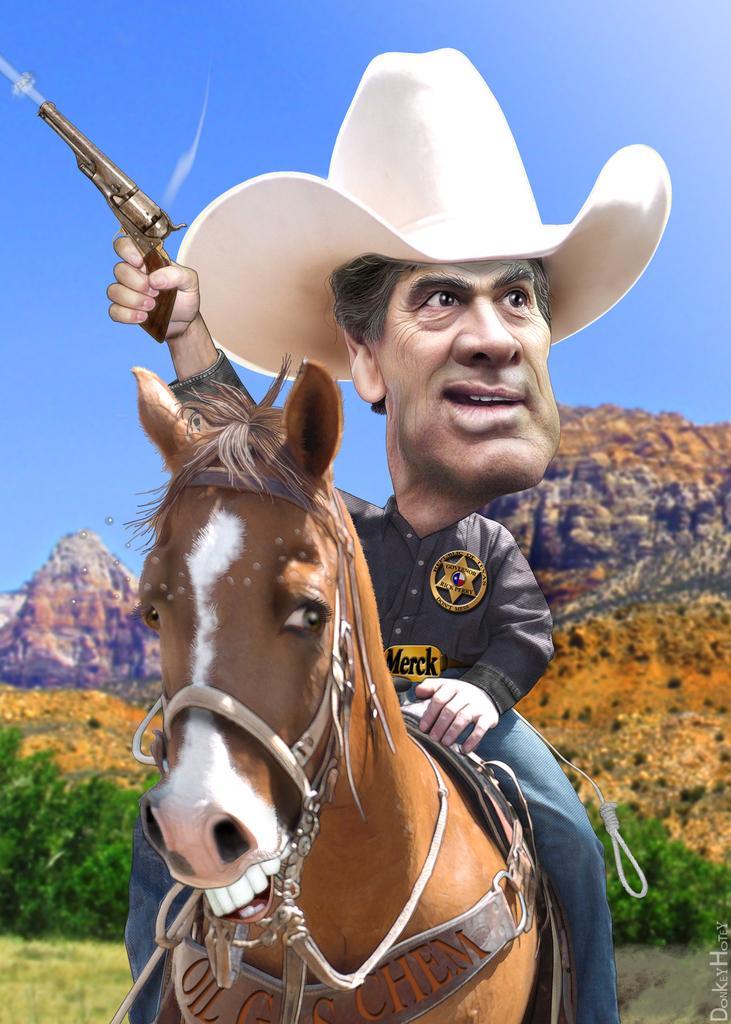Describe this image in one or two sentences. This is an edited image and here we can see a person sitting on the horse and wearing a hat and a badge and holding a gun. In the background, there are hills and we can see trees and at the bottom, there is some text and there is ground. At the top, there is sky. 